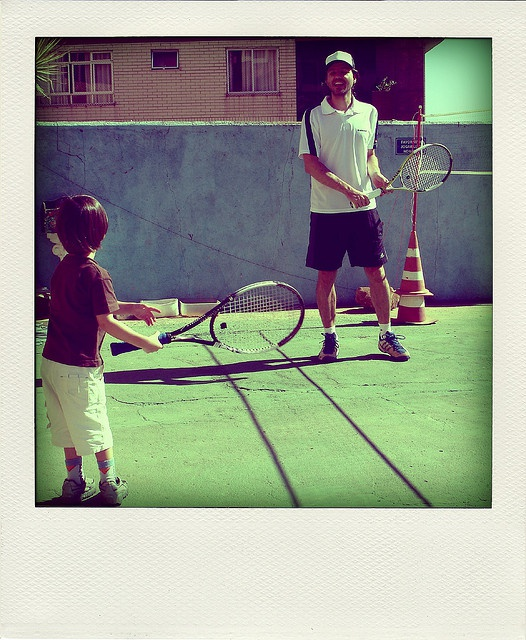Describe the objects in this image and their specific colors. I can see people in lightgray, navy, olive, and purple tones, people in lightgray, navy, darkgray, and purple tones, tennis racket in lightgray, lightgreen, gray, and navy tones, and tennis racket in lightgray, gray, darkgray, lightgreen, and black tones in this image. 